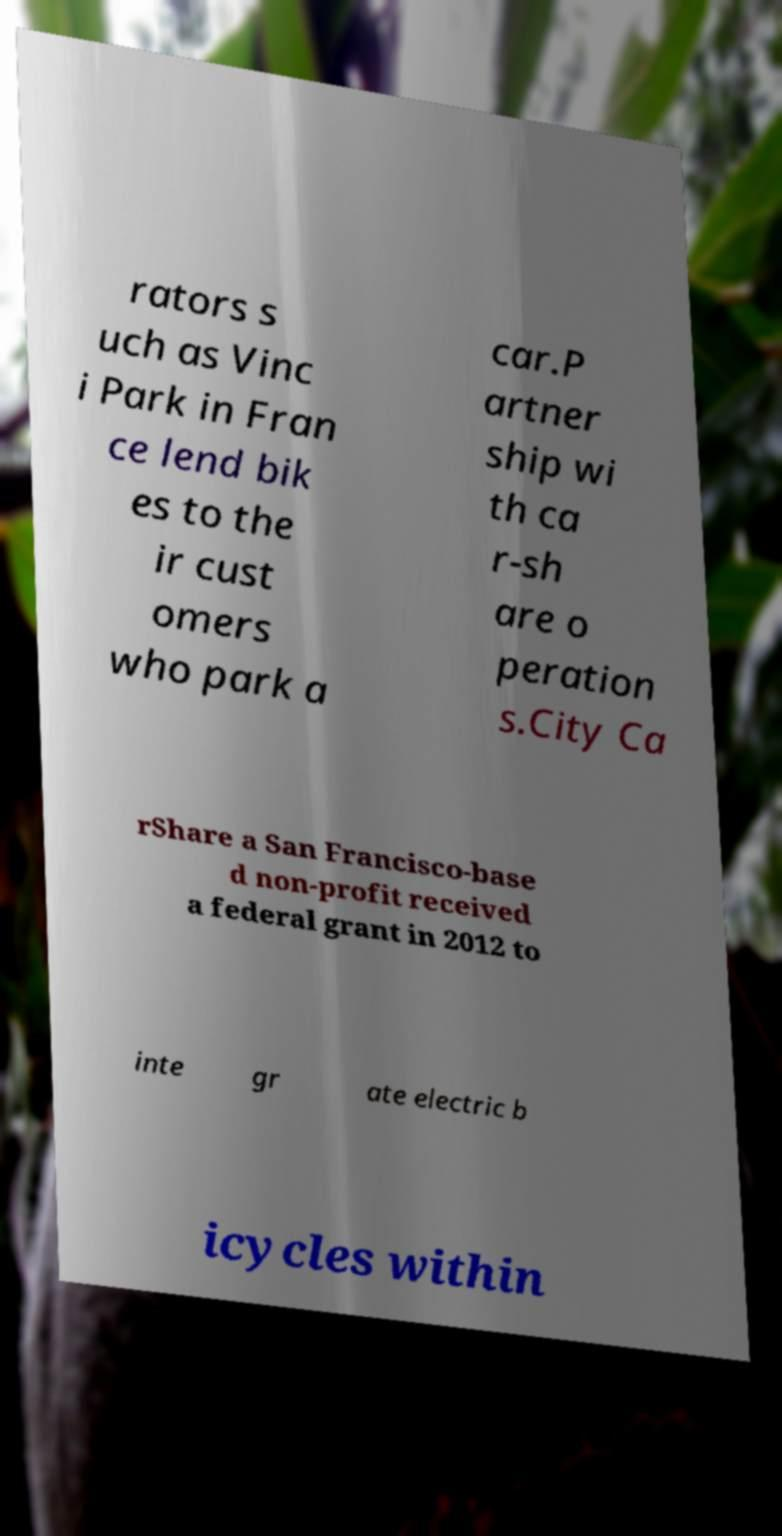Can you accurately transcribe the text from the provided image for me? rators s uch as Vinc i Park in Fran ce lend bik es to the ir cust omers who park a car.P artner ship wi th ca r-sh are o peration s.City Ca rShare a San Francisco-base d non-profit received a federal grant in 2012 to inte gr ate electric b icycles within 